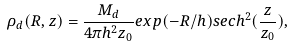Convert formula to latex. <formula><loc_0><loc_0><loc_500><loc_500>\rho _ { d } ( R , z ) = \frac { M _ { d } } { 4 \pi h ^ { 2 } z _ { 0 } } e x p ( - R / h ) s e c h ^ { 2 } ( \frac { z } { z _ { 0 } } ) ,</formula> 